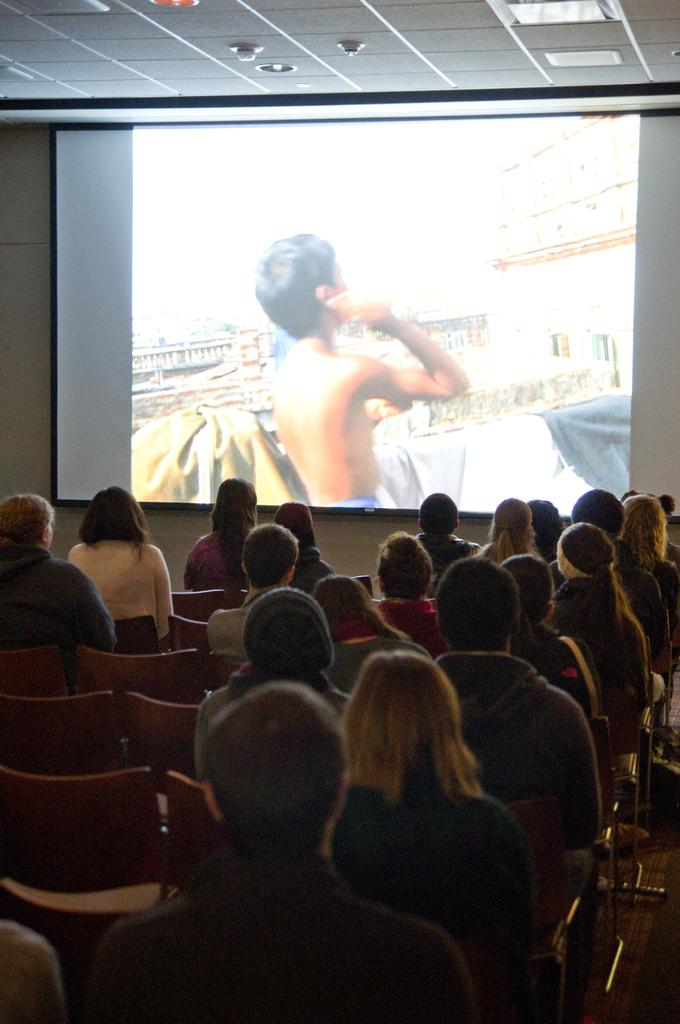What are the people in the image doing? The people in the image are sitting on chairs. Are all the chairs occupied in the image? No, some chairs are empty in the image. What can be seen in the background of the image? There is a screen in the background of the image. Who or what is visible on the screen? A man is visible on the screen. What is present above the people in the image? There is a ceiling in the image. What is providing illumination in the image? Lights are present in the image. What type of plantation is visible in the image? There is no plantation present in the image. What kind of meat is being served to the people in the image? There is no meat visible in the image; it is not mentioned in the provided facts. 